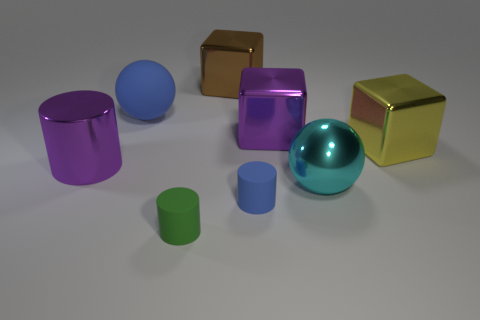Add 1 big cyan cylinders. How many objects exist? 9 Subtract all cubes. How many objects are left? 5 Add 3 large cyan objects. How many large cyan objects are left? 4 Add 8 yellow metallic blocks. How many yellow metallic blocks exist? 9 Subtract 1 blue balls. How many objects are left? 7 Subtract all tiny red objects. Subtract all cyan balls. How many objects are left? 7 